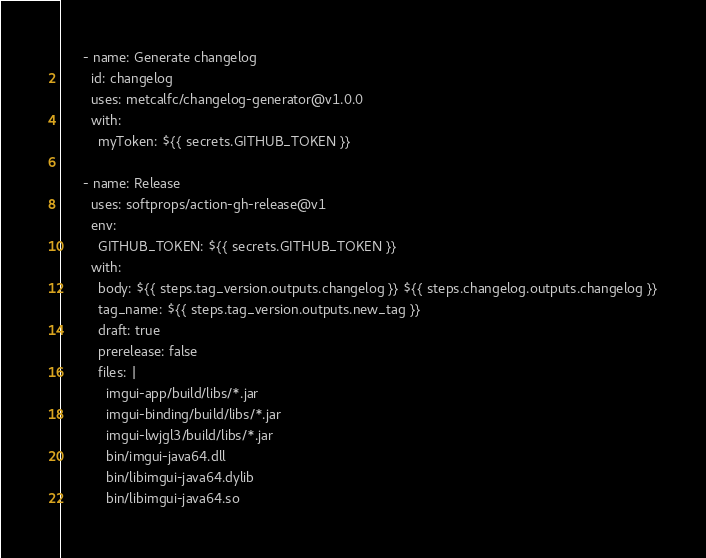<code> <loc_0><loc_0><loc_500><loc_500><_YAML_>      - name: Generate changelog
        id: changelog
        uses: metcalfc/changelog-generator@v1.0.0
        with:
          myToken: ${{ secrets.GITHUB_TOKEN }}

      - name: Release
        uses: softprops/action-gh-release@v1
        env:
          GITHUB_TOKEN: ${{ secrets.GITHUB_TOKEN }}
        with:
          body: ${{ steps.tag_version.outputs.changelog }} ${{ steps.changelog.outputs.changelog }}
          tag_name: ${{ steps.tag_version.outputs.new_tag }}
          draft: true
          prerelease: false
          files: |
            imgui-app/build/libs/*.jar
            imgui-binding/build/libs/*.jar
            imgui-lwjgl3/build/libs/*.jar
            bin/imgui-java64.dll
            bin/libimgui-java64.dylib
            bin/libimgui-java64.so
</code> 